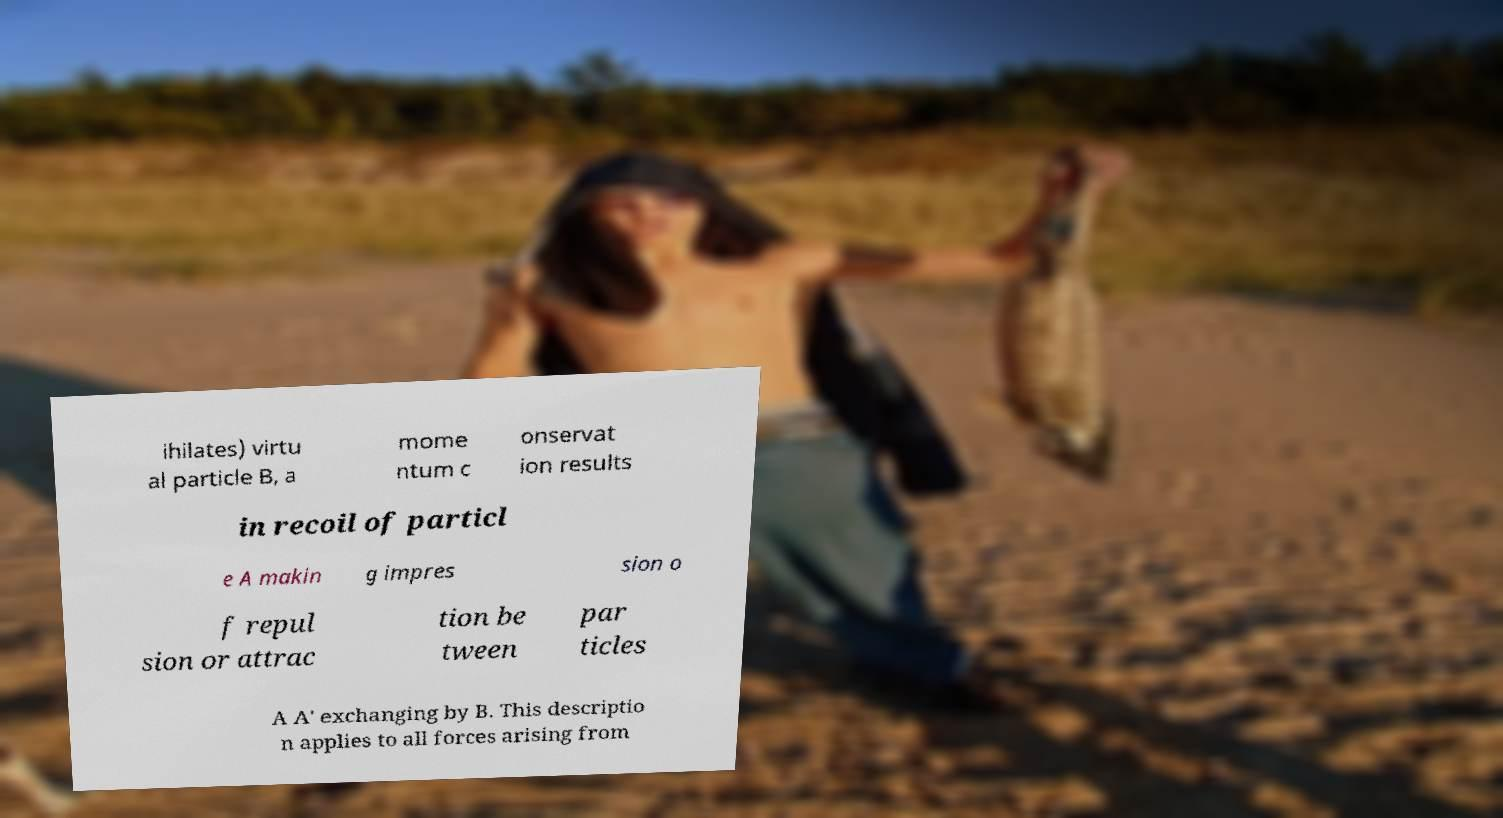I need the written content from this picture converted into text. Can you do that? ihilates) virtu al particle B, a mome ntum c onservat ion results in recoil of particl e A makin g impres sion o f repul sion or attrac tion be tween par ticles A A' exchanging by B. This descriptio n applies to all forces arising from 